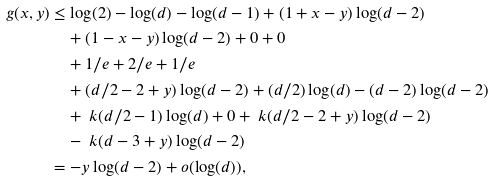<formula> <loc_0><loc_0><loc_500><loc_500>g ( x , y ) & \leq \log ( 2 ) - \log ( d ) - \log ( d - 1 ) + ( 1 + x - y ) \log ( d - 2 ) \\ & \quad + ( 1 - x - y ) \log ( d - 2 ) + 0 + 0 \\ & \quad + 1 / e + 2 / e + 1 / e \\ & \quad + ( d / 2 - 2 + y ) \log ( d - 2 ) + ( d / 2 ) \log ( d ) - ( d - 2 ) \log ( d - 2 ) \\ & \quad + { \ k } ( d / 2 - 1 ) \log ( d ) + 0 + { \ k } ( d / 2 - 2 + y ) \log ( d - 2 ) \\ & \quad - { \ k } ( d - 3 + y ) \log ( d - 2 ) \\ & = - y \log ( d - 2 ) + o ( \log ( d ) ) ,</formula> 